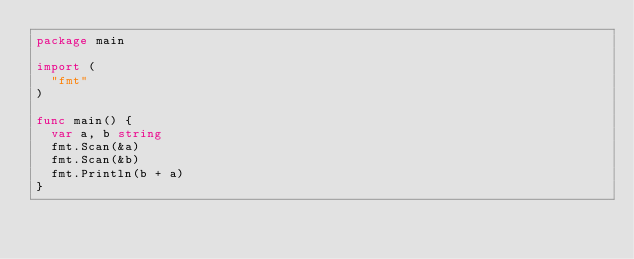<code> <loc_0><loc_0><loc_500><loc_500><_Go_>package main

import (
	"fmt"
)

func main() {
	var a, b string
	fmt.Scan(&a)
	fmt.Scan(&b)
	fmt.Println(b + a)
}
</code> 